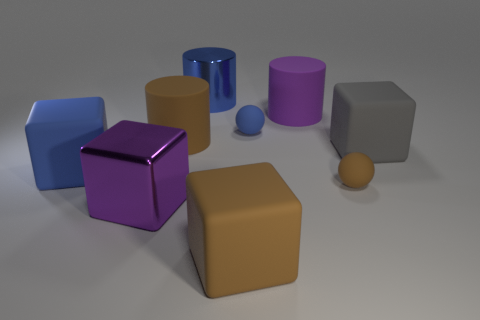What is the shape of the large rubber thing that is the same color as the large shiny block?
Offer a terse response. Cylinder. The big metal cylinder has what color?
Make the answer very short. Blue. There is a big metal object behind the gray block; is it the same shape as the purple shiny object?
Your answer should be very brief. No. How many things are either blue cylinders that are behind the gray object or shiny cylinders?
Ensure brevity in your answer.  1. Are there any big purple things of the same shape as the big blue rubber object?
Offer a very short reply. Yes. There is a gray thing that is the same size as the brown rubber cylinder; what is its shape?
Offer a terse response. Cube. The big purple thing that is in front of the cube on the right side of the large brown thing that is in front of the blue rubber cube is what shape?
Give a very brief answer. Cube. There is a gray object; does it have the same shape as the purple thing behind the gray object?
Your answer should be very brief. No. How many tiny things are either matte cylinders or cylinders?
Your response must be concise. 0. Is there another brown block that has the same size as the brown block?
Give a very brief answer. No. 